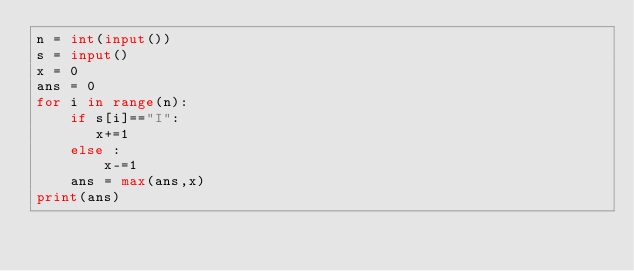Convert code to text. <code><loc_0><loc_0><loc_500><loc_500><_Python_>n = int(input())
s = input()
x = 0
ans = 0
for i in range(n):
    if s[i]=="I":
       x+=1
    else :
        x-=1
    ans = max(ans,x)
print(ans) </code> 